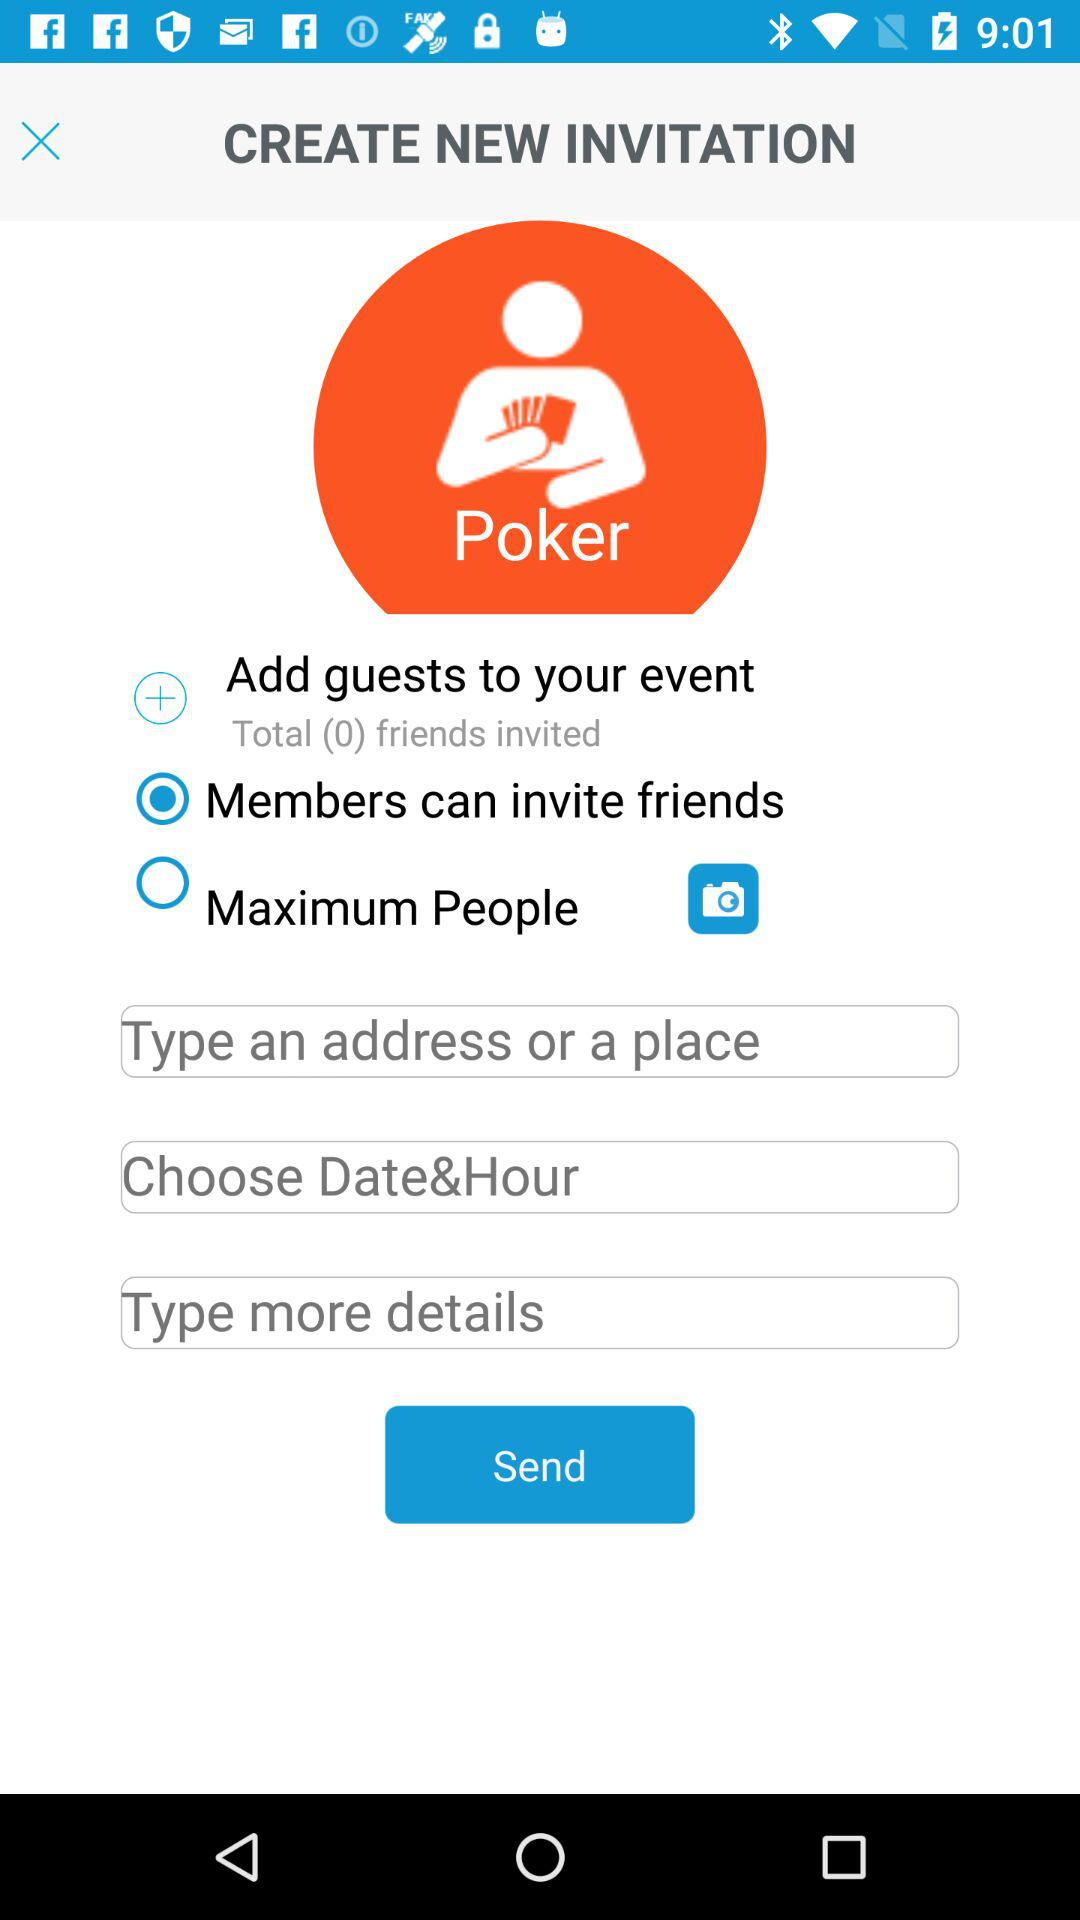Which date and hour are chosen?
When the provided information is insufficient, respond with <no answer>. <no answer> 